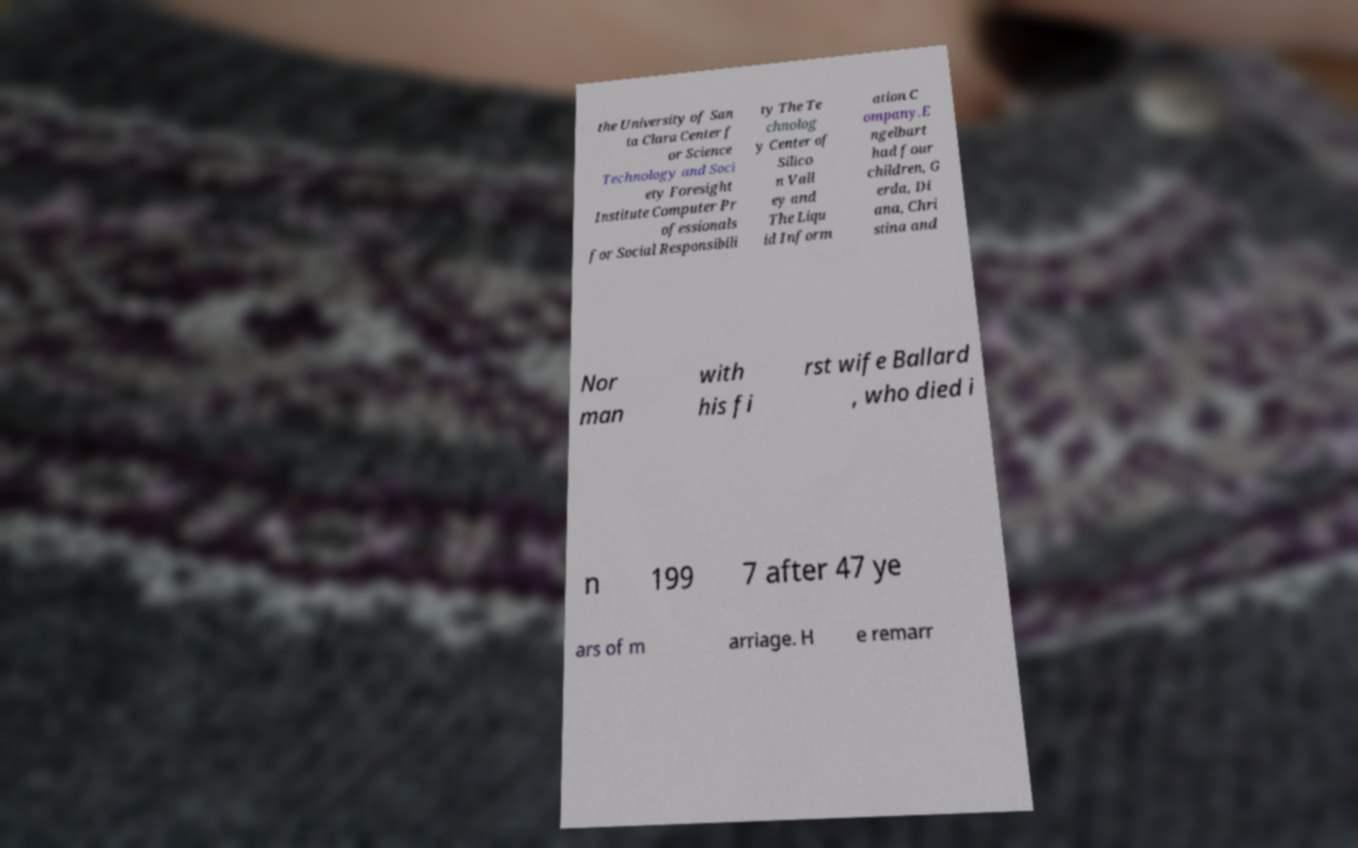Could you extract and type out the text from this image? the University of San ta Clara Center f or Science Technology and Soci ety Foresight Institute Computer Pr ofessionals for Social Responsibili ty The Te chnolog y Center of Silico n Vall ey and The Liqu id Inform ation C ompany.E ngelbart had four children, G erda, Di ana, Chri stina and Nor man with his fi rst wife Ballard , who died i n 199 7 after 47 ye ars of m arriage. H e remarr 